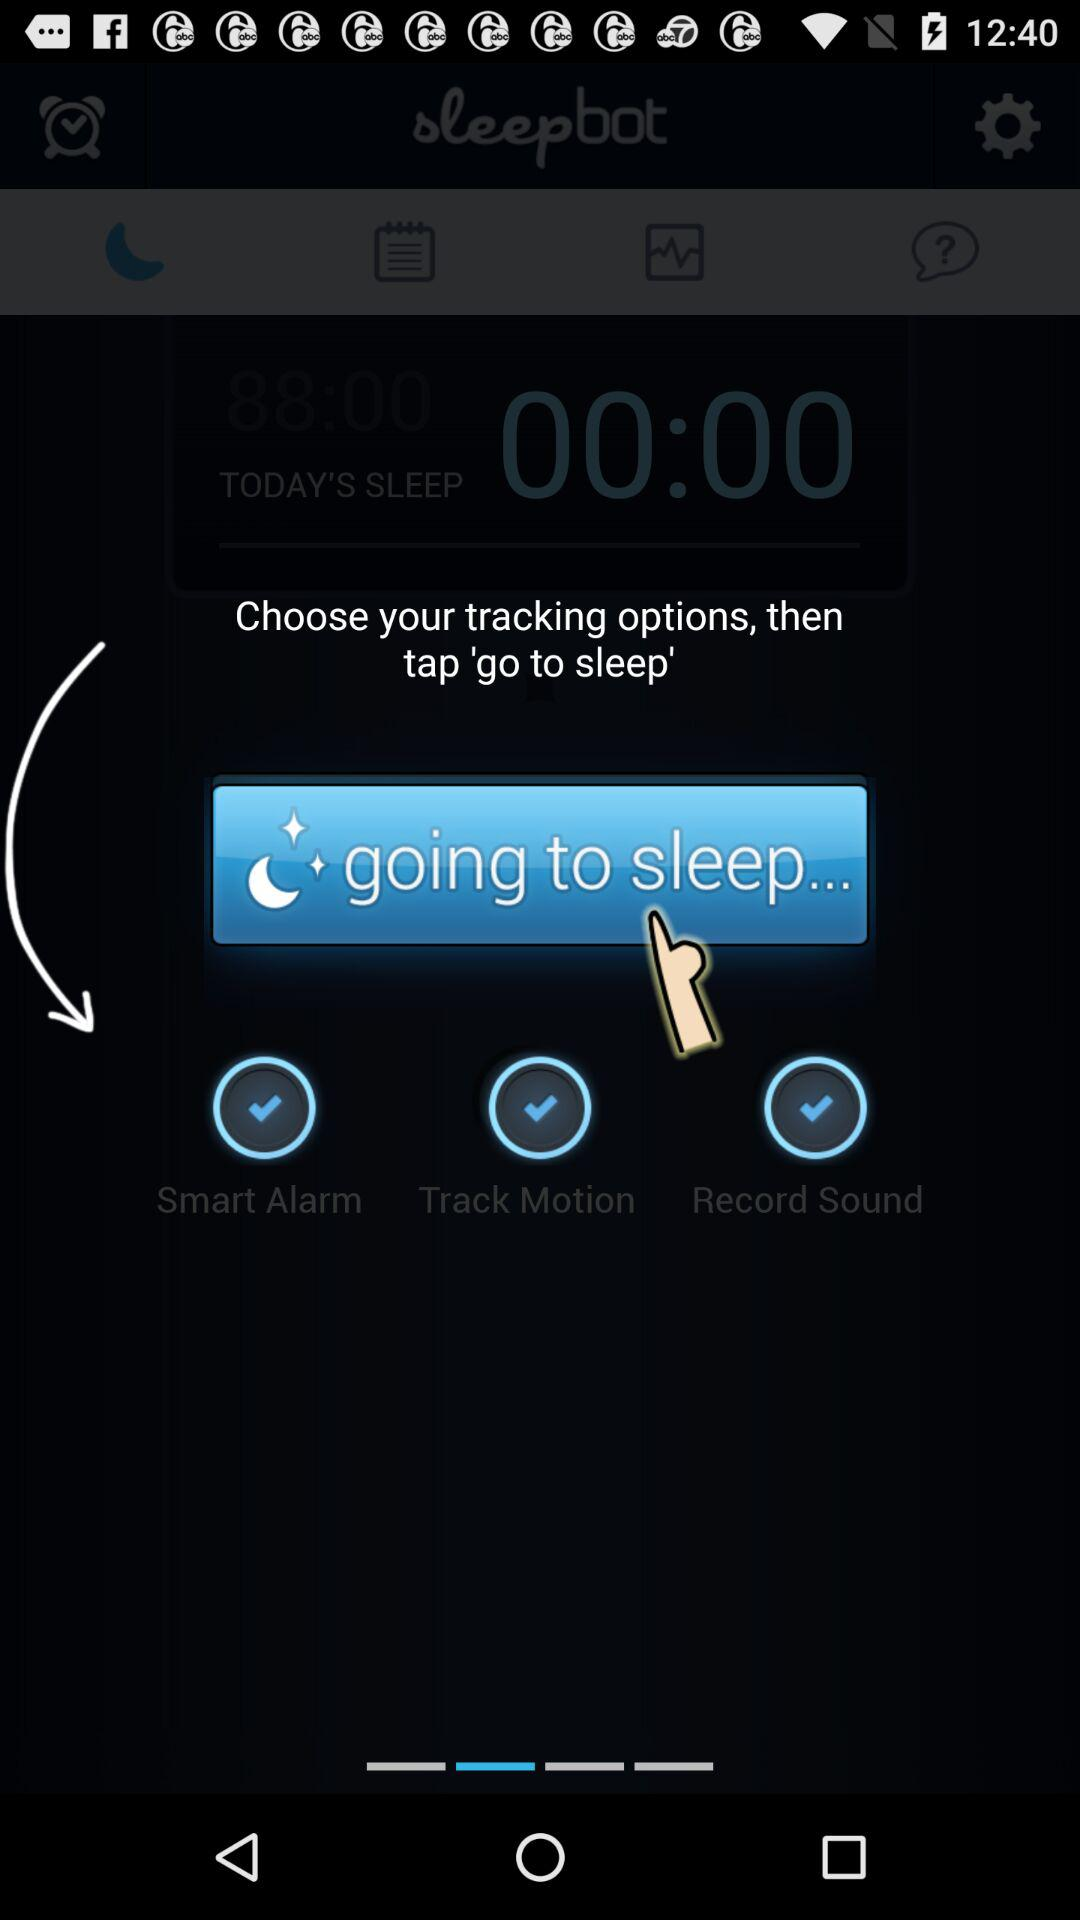What do we need to choose before going to sleep? Before going to sleep, you need to choose tracking options. 